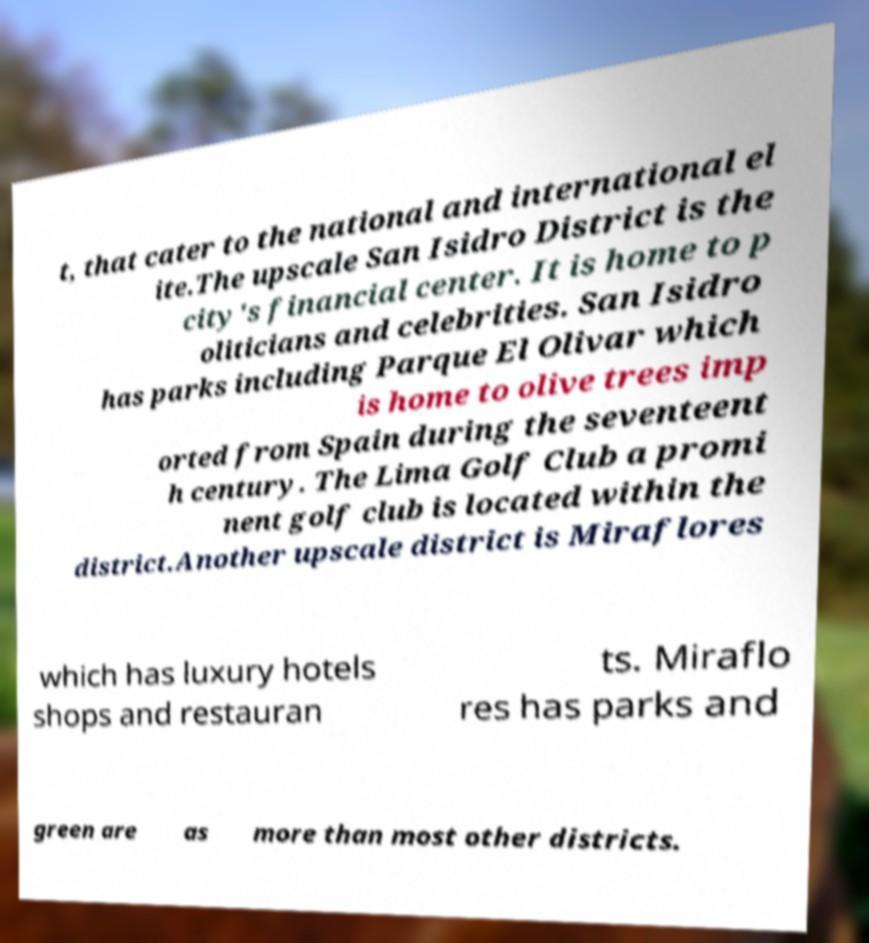For documentation purposes, I need the text within this image transcribed. Could you provide that? t, that cater to the national and international el ite.The upscale San Isidro District is the city's financial center. It is home to p oliticians and celebrities. San Isidro has parks including Parque El Olivar which is home to olive trees imp orted from Spain during the seventeent h century. The Lima Golf Club a promi nent golf club is located within the district.Another upscale district is Miraflores which has luxury hotels shops and restauran ts. Miraflo res has parks and green are as more than most other districts. 